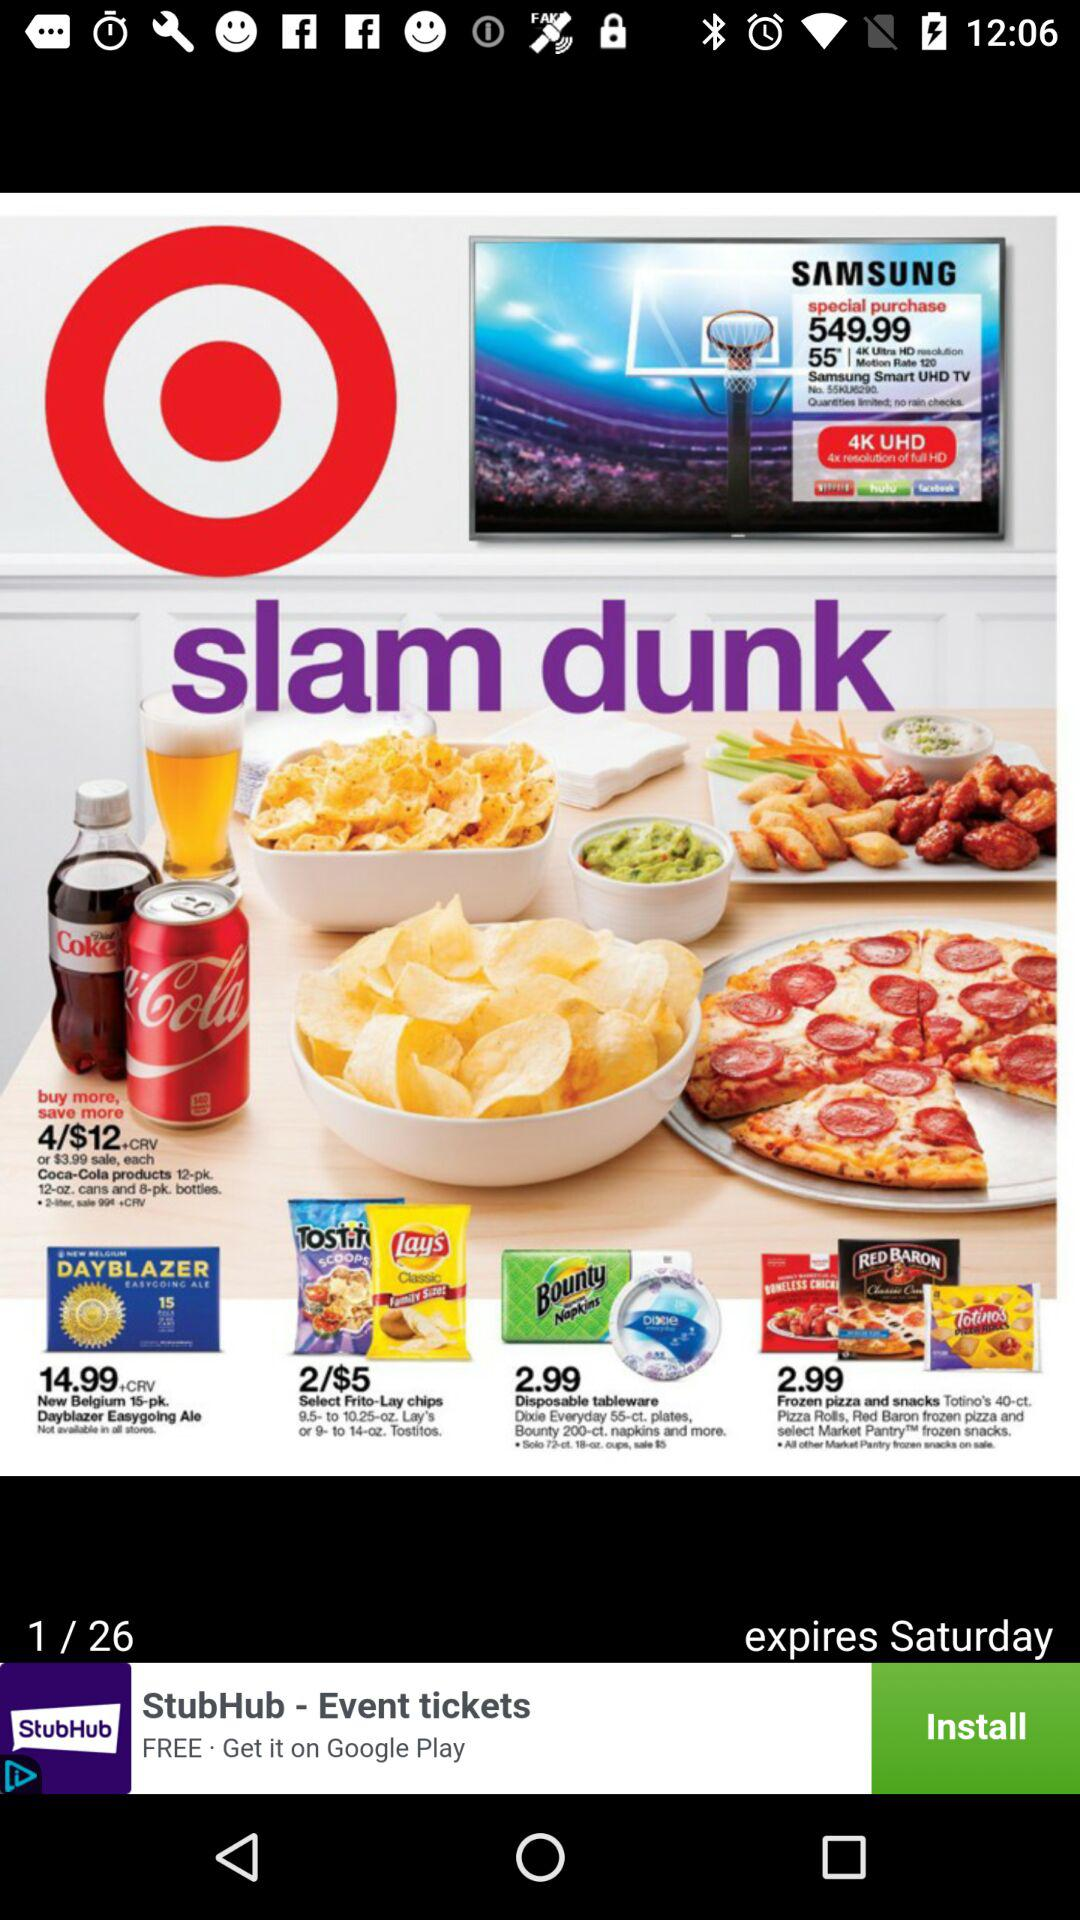How many total pages are there? There are 26 total pages. 